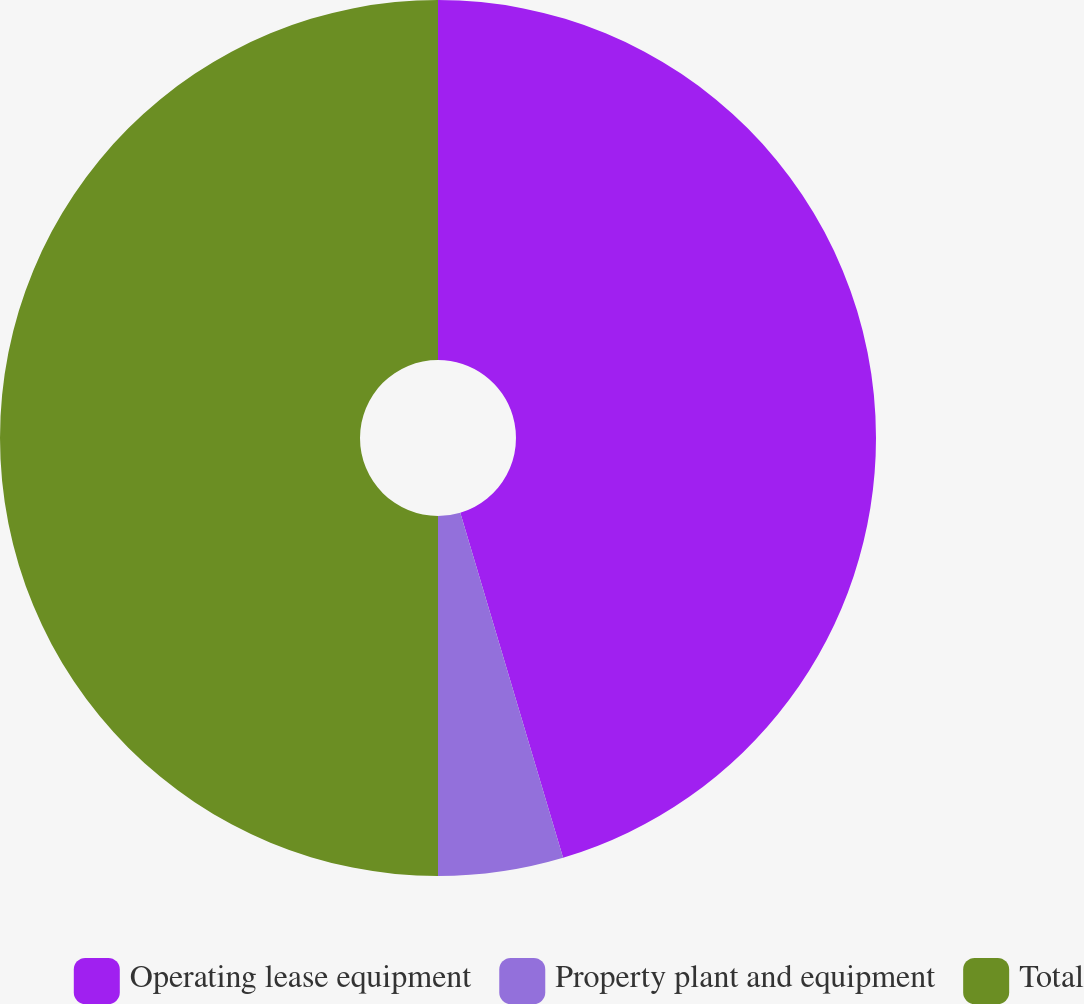Convert chart to OTSL. <chart><loc_0><loc_0><loc_500><loc_500><pie_chart><fcel>Operating lease equipment<fcel>Property plant and equipment<fcel>Total<nl><fcel>45.39%<fcel>4.61%<fcel>50.0%<nl></chart> 